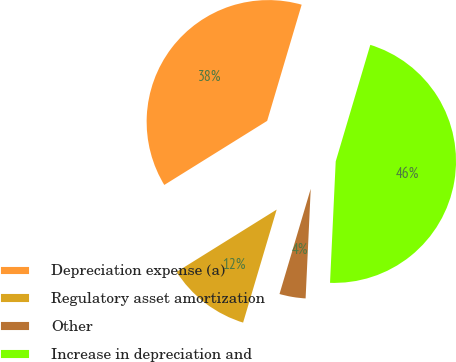Convert chart to OTSL. <chart><loc_0><loc_0><loc_500><loc_500><pie_chart><fcel>Depreciation expense (a)<fcel>Regulatory asset amortization<fcel>Other<fcel>Increase in depreciation and<nl><fcel>38.46%<fcel>11.54%<fcel>3.85%<fcel>46.15%<nl></chart> 